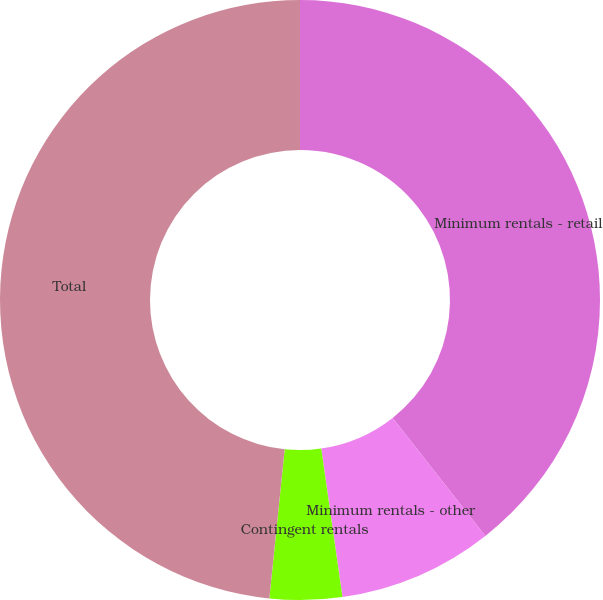Convert chart. <chart><loc_0><loc_0><loc_500><loc_500><pie_chart><fcel>Minimum rentals - retail<fcel>Minimum rentals - other<fcel>Contingent rentals<fcel>Total<nl><fcel>39.4%<fcel>8.34%<fcel>3.89%<fcel>48.37%<nl></chart> 